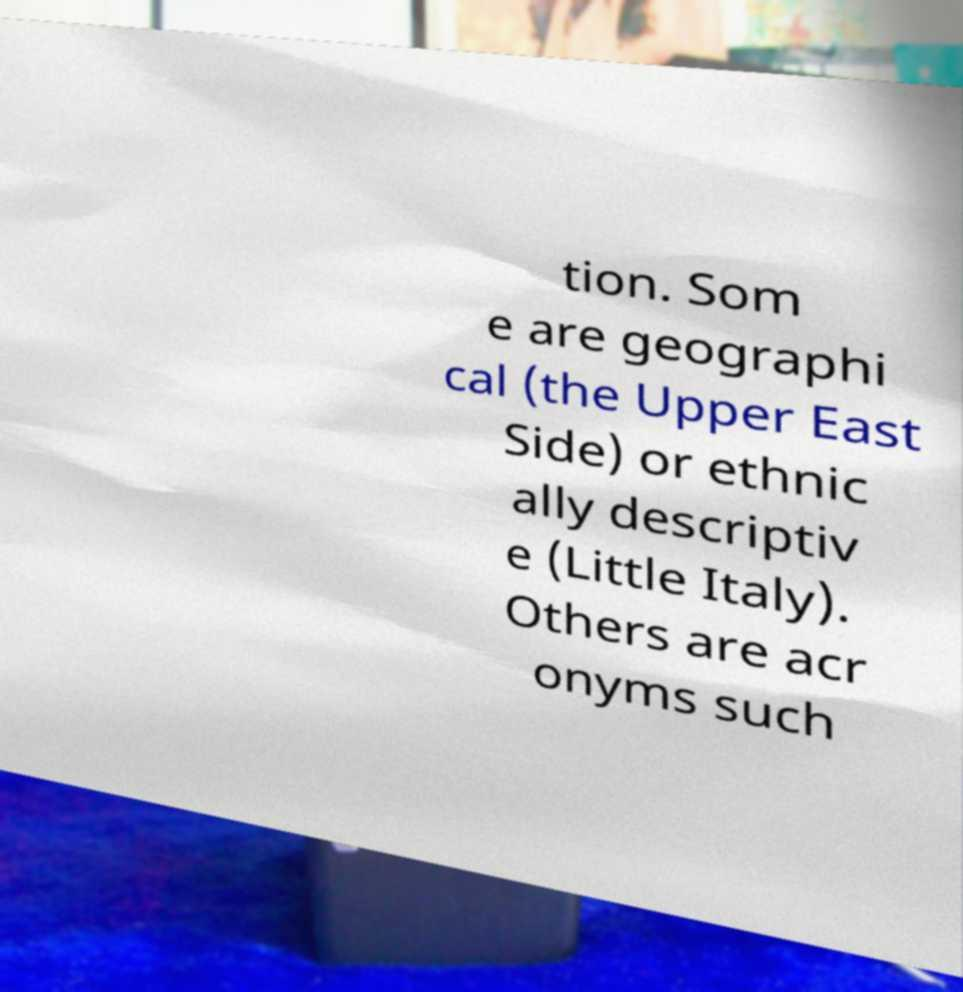Can you accurately transcribe the text from the provided image for me? tion. Som e are geographi cal (the Upper East Side) or ethnic ally descriptiv e (Little Italy). Others are acr onyms such 